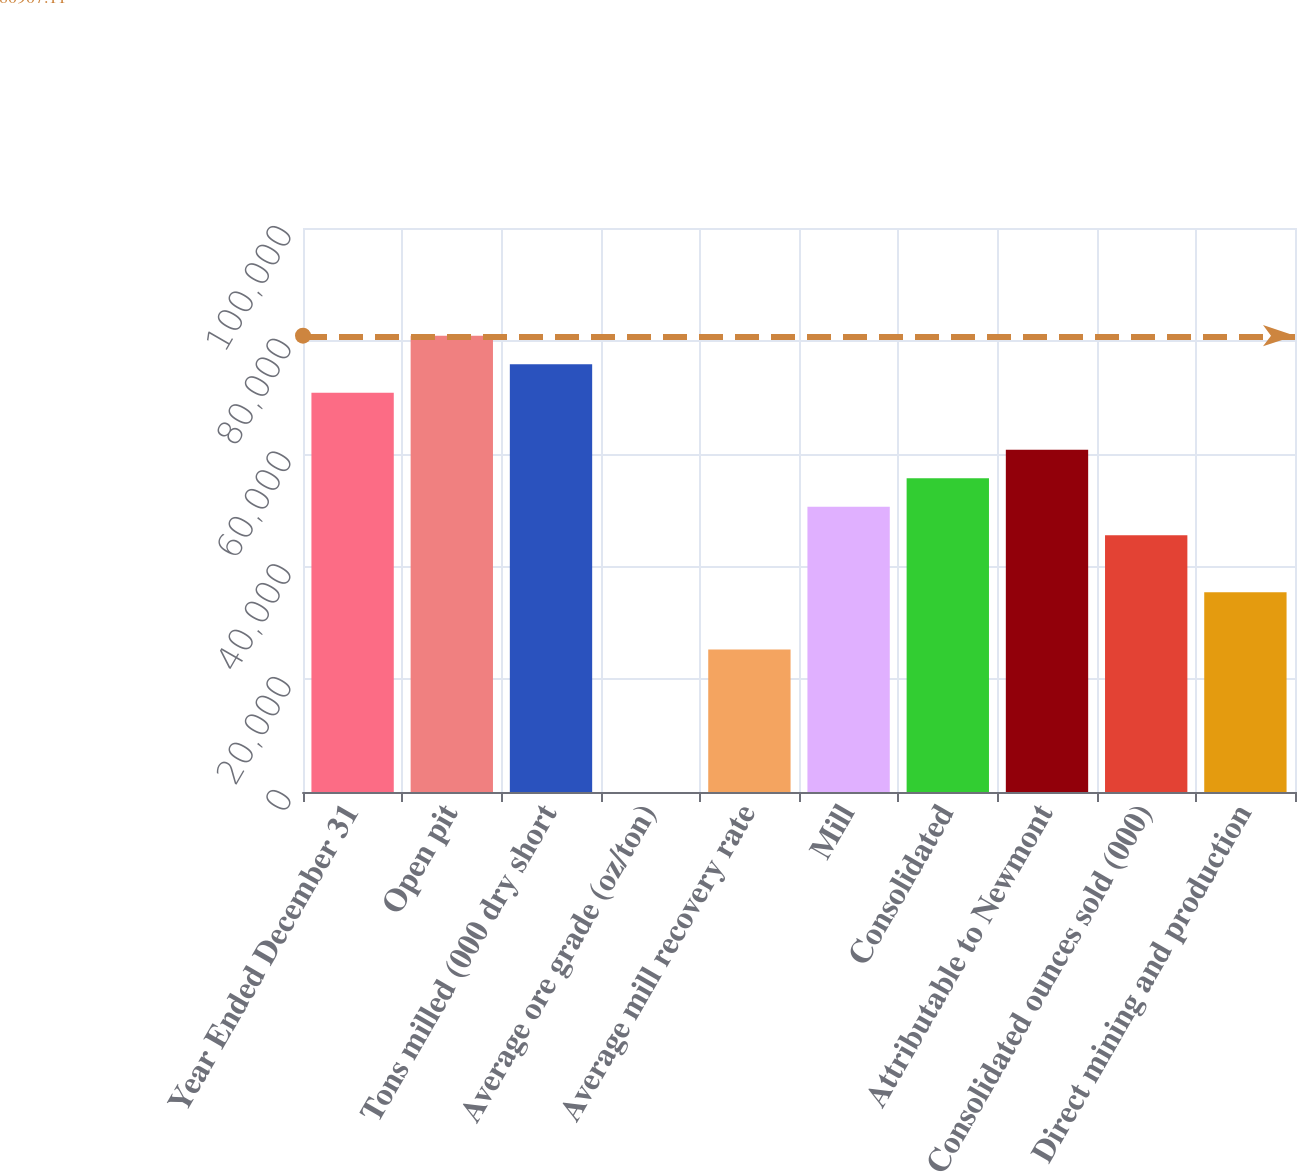<chart> <loc_0><loc_0><loc_500><loc_500><bar_chart><fcel>Year Ended December 31<fcel>Open pit<fcel>Tons milled (000 dry short<fcel>Average ore grade (oz/ton)<fcel>Average mill recovery rate<fcel>Mill<fcel>Consolidated<fcel>Attributable to Newmont<fcel>Consolidated ounces sold (000)<fcel>Direct mining and production<nl><fcel>70793.7<fcel>80907.1<fcel>75850.4<fcel>0.07<fcel>25283.5<fcel>50567<fcel>55623.7<fcel>60680.3<fcel>45510.3<fcel>35396.9<nl></chart> 